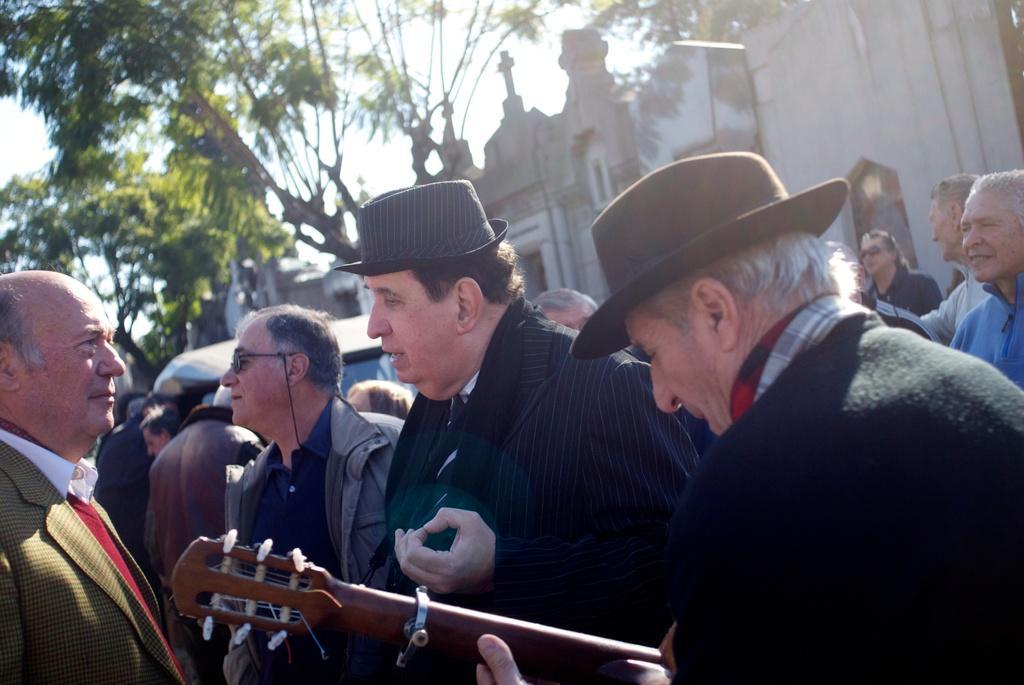Can you describe this image briefly? In this picture I can see a man in front, who is holding an musical instrument and I see that he is wearing a hat and in front of him I see another man, who is also wearing a hat and I see number of people. In the background I see the buildings and the trees. 